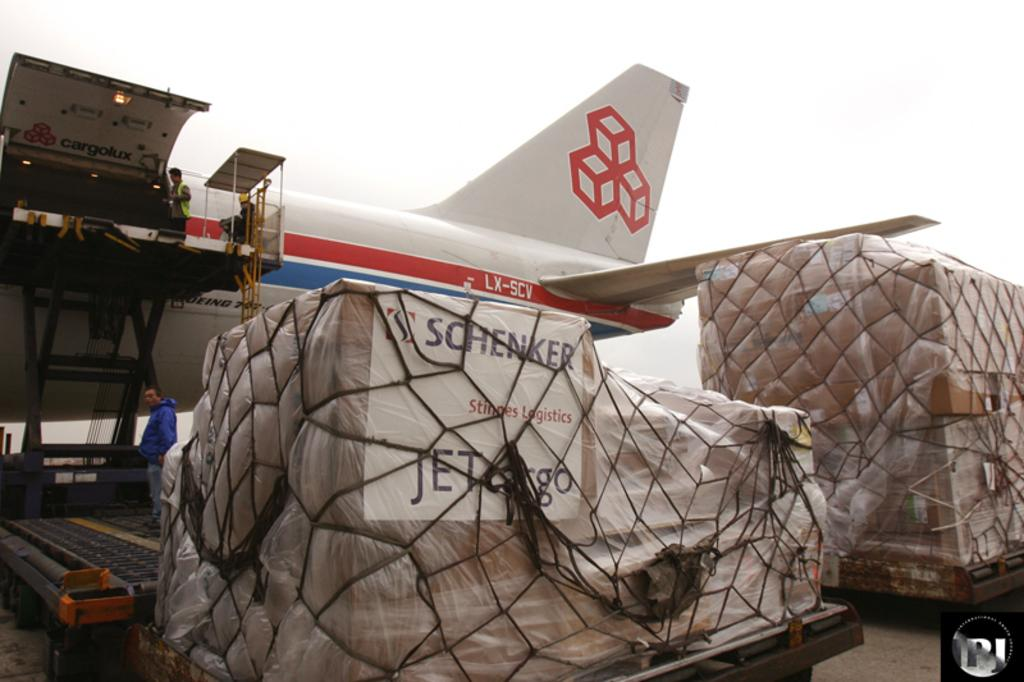What can be seen in the image? There are objects in the image, including a plane and a few persons. Can you describe the plane in the image? There is a plane in the image. What are the persons doing near the plane? The persons are beside the plane, but their actions are not specified in the given facts. What type of rabbit can be seen wearing a cloth and holding a drink in the image? There is no rabbit, cloth, or drink present in the image. 